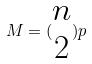Convert formula to latex. <formula><loc_0><loc_0><loc_500><loc_500>M = ( \begin{matrix} n \\ 2 \end{matrix} ) p</formula> 